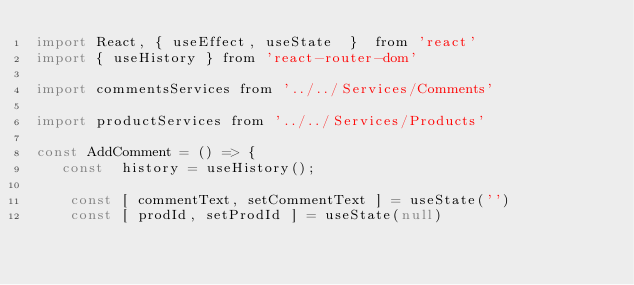<code> <loc_0><loc_0><loc_500><loc_500><_JavaScript_>import React, { useEffect, useState  }  from 'react'
import { useHistory } from 'react-router-dom'

import commentsServices from '../../Services/Comments'

import productServices from '../../Services/Products'

const AddComment = () => {
   const  history = useHistory();

    const [ commentText, setCommentText ] = useState('')
    const [ prodId, setProdId ] = useState(null)</code> 